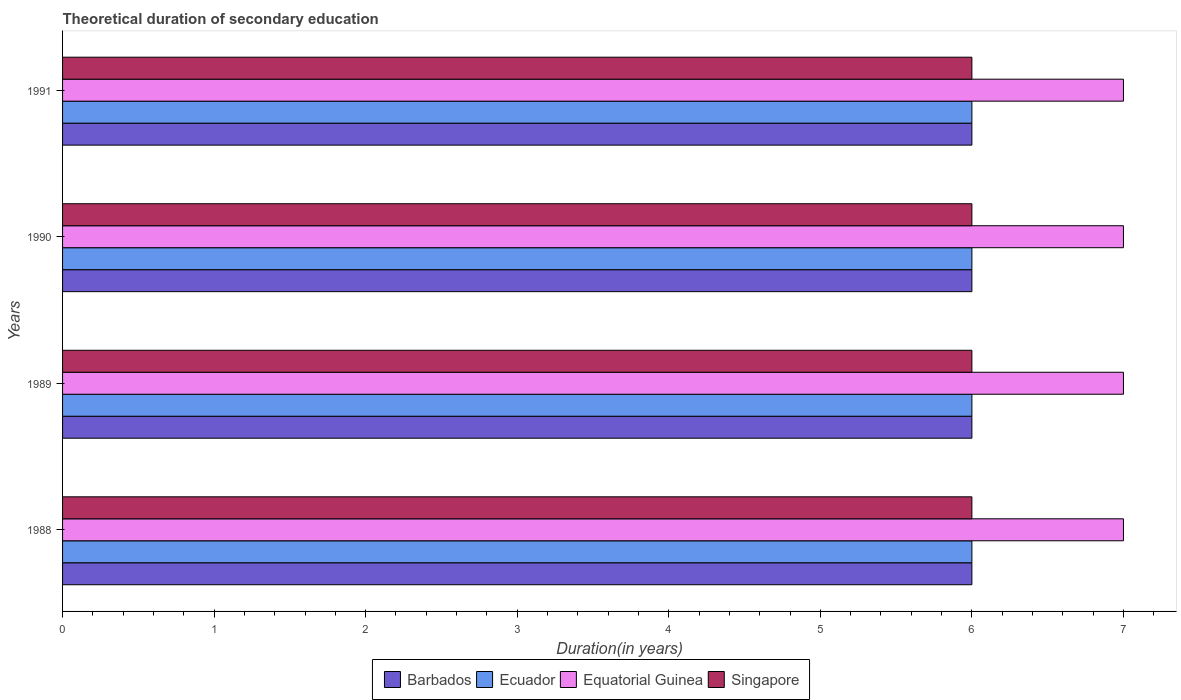How many different coloured bars are there?
Provide a succinct answer. 4. How many groups of bars are there?
Provide a short and direct response. 4. Are the number of bars per tick equal to the number of legend labels?
Provide a short and direct response. Yes. Are the number of bars on each tick of the Y-axis equal?
Your response must be concise. Yes. What is the total theoretical duration of secondary education in Equatorial Guinea in 1990?
Provide a short and direct response. 7. Across all years, what is the maximum total theoretical duration of secondary education in Ecuador?
Provide a short and direct response. 6. Across all years, what is the minimum total theoretical duration of secondary education in Equatorial Guinea?
Give a very brief answer. 7. What is the total total theoretical duration of secondary education in Barbados in the graph?
Keep it short and to the point. 24. What is the difference between the total theoretical duration of secondary education in Equatorial Guinea in 1989 and that in 1990?
Offer a terse response. 0. What is the difference between the total theoretical duration of secondary education in Singapore in 1990 and the total theoretical duration of secondary education in Equatorial Guinea in 1991?
Your answer should be compact. -1. In how many years, is the total theoretical duration of secondary education in Ecuador greater than 6 years?
Offer a very short reply. 0. What is the ratio of the total theoretical duration of secondary education in Singapore in 1989 to that in 1990?
Make the answer very short. 1. What is the difference between the highest and the second highest total theoretical duration of secondary education in Singapore?
Provide a succinct answer. 0. In how many years, is the total theoretical duration of secondary education in Ecuador greater than the average total theoretical duration of secondary education in Ecuador taken over all years?
Make the answer very short. 0. Is it the case that in every year, the sum of the total theoretical duration of secondary education in Barbados and total theoretical duration of secondary education in Ecuador is greater than the sum of total theoretical duration of secondary education in Singapore and total theoretical duration of secondary education in Equatorial Guinea?
Your answer should be very brief. No. What does the 2nd bar from the top in 1990 represents?
Keep it short and to the point. Equatorial Guinea. What does the 2nd bar from the bottom in 1988 represents?
Your response must be concise. Ecuador. Is it the case that in every year, the sum of the total theoretical duration of secondary education in Barbados and total theoretical duration of secondary education in Singapore is greater than the total theoretical duration of secondary education in Ecuador?
Make the answer very short. Yes. Are all the bars in the graph horizontal?
Provide a succinct answer. Yes. How many years are there in the graph?
Your answer should be very brief. 4. Are the values on the major ticks of X-axis written in scientific E-notation?
Make the answer very short. No. Where does the legend appear in the graph?
Your response must be concise. Bottom center. How many legend labels are there?
Keep it short and to the point. 4. What is the title of the graph?
Make the answer very short. Theoretical duration of secondary education. What is the label or title of the X-axis?
Your answer should be compact. Duration(in years). What is the label or title of the Y-axis?
Ensure brevity in your answer.  Years. What is the Duration(in years) of Ecuador in 1988?
Offer a very short reply. 6. What is the Duration(in years) of Equatorial Guinea in 1988?
Provide a short and direct response. 7. What is the Duration(in years) in Barbados in 1989?
Keep it short and to the point. 6. What is the Duration(in years) of Ecuador in 1989?
Keep it short and to the point. 6. What is the Duration(in years) in Equatorial Guinea in 1989?
Your answer should be compact. 7. What is the Duration(in years) in Singapore in 1989?
Give a very brief answer. 6. What is the Duration(in years) of Barbados in 1990?
Your answer should be very brief. 6. What is the Duration(in years) in Barbados in 1991?
Your answer should be very brief. 6. Across all years, what is the maximum Duration(in years) of Barbados?
Offer a very short reply. 6. Across all years, what is the maximum Duration(in years) of Ecuador?
Make the answer very short. 6. Across all years, what is the maximum Duration(in years) in Equatorial Guinea?
Offer a very short reply. 7. Across all years, what is the minimum Duration(in years) of Barbados?
Your response must be concise. 6. What is the total Duration(in years) of Barbados in the graph?
Provide a short and direct response. 24. What is the total Duration(in years) in Equatorial Guinea in the graph?
Provide a succinct answer. 28. What is the difference between the Duration(in years) in Barbados in 1988 and that in 1989?
Offer a terse response. 0. What is the difference between the Duration(in years) of Ecuador in 1988 and that in 1989?
Your response must be concise. 0. What is the difference between the Duration(in years) of Singapore in 1988 and that in 1989?
Provide a short and direct response. 0. What is the difference between the Duration(in years) in Barbados in 1988 and that in 1990?
Keep it short and to the point. 0. What is the difference between the Duration(in years) in Ecuador in 1988 and that in 1990?
Give a very brief answer. 0. What is the difference between the Duration(in years) of Equatorial Guinea in 1988 and that in 1990?
Your response must be concise. 0. What is the difference between the Duration(in years) of Singapore in 1988 and that in 1990?
Give a very brief answer. 0. What is the difference between the Duration(in years) in Ecuador in 1988 and that in 1991?
Offer a terse response. 0. What is the difference between the Duration(in years) in Equatorial Guinea in 1988 and that in 1991?
Ensure brevity in your answer.  0. What is the difference between the Duration(in years) of Singapore in 1988 and that in 1991?
Offer a very short reply. 0. What is the difference between the Duration(in years) of Ecuador in 1989 and that in 1990?
Provide a succinct answer. 0. What is the difference between the Duration(in years) in Singapore in 1989 and that in 1990?
Offer a terse response. 0. What is the difference between the Duration(in years) of Equatorial Guinea in 1990 and that in 1991?
Your answer should be compact. 0. What is the difference between the Duration(in years) of Singapore in 1990 and that in 1991?
Your response must be concise. 0. What is the difference between the Duration(in years) of Equatorial Guinea in 1988 and the Duration(in years) of Singapore in 1989?
Provide a succinct answer. 1. What is the difference between the Duration(in years) in Barbados in 1988 and the Duration(in years) in Ecuador in 1990?
Provide a succinct answer. 0. What is the difference between the Duration(in years) of Barbados in 1988 and the Duration(in years) of Equatorial Guinea in 1990?
Ensure brevity in your answer.  -1. What is the difference between the Duration(in years) in Ecuador in 1988 and the Duration(in years) in Singapore in 1990?
Make the answer very short. 0. What is the difference between the Duration(in years) in Barbados in 1988 and the Duration(in years) in Ecuador in 1991?
Offer a very short reply. 0. What is the difference between the Duration(in years) of Barbados in 1988 and the Duration(in years) of Equatorial Guinea in 1991?
Keep it short and to the point. -1. What is the difference between the Duration(in years) of Ecuador in 1988 and the Duration(in years) of Equatorial Guinea in 1991?
Keep it short and to the point. -1. What is the difference between the Duration(in years) in Ecuador in 1988 and the Duration(in years) in Singapore in 1991?
Offer a terse response. 0. What is the difference between the Duration(in years) of Equatorial Guinea in 1988 and the Duration(in years) of Singapore in 1991?
Ensure brevity in your answer.  1. What is the difference between the Duration(in years) of Barbados in 1989 and the Duration(in years) of Ecuador in 1990?
Keep it short and to the point. 0. What is the difference between the Duration(in years) in Ecuador in 1989 and the Duration(in years) in Equatorial Guinea in 1990?
Ensure brevity in your answer.  -1. What is the difference between the Duration(in years) in Barbados in 1989 and the Duration(in years) in Equatorial Guinea in 1991?
Offer a very short reply. -1. What is the difference between the Duration(in years) of Equatorial Guinea in 1989 and the Duration(in years) of Singapore in 1991?
Your response must be concise. 1. What is the difference between the Duration(in years) of Equatorial Guinea in 1990 and the Duration(in years) of Singapore in 1991?
Your answer should be very brief. 1. What is the average Duration(in years) of Barbados per year?
Your answer should be very brief. 6. In the year 1988, what is the difference between the Duration(in years) of Barbados and Duration(in years) of Equatorial Guinea?
Provide a succinct answer. -1. In the year 1988, what is the difference between the Duration(in years) of Barbados and Duration(in years) of Singapore?
Keep it short and to the point. 0. In the year 1988, what is the difference between the Duration(in years) in Ecuador and Duration(in years) in Equatorial Guinea?
Make the answer very short. -1. In the year 1989, what is the difference between the Duration(in years) of Barbados and Duration(in years) of Ecuador?
Your answer should be very brief. 0. In the year 1990, what is the difference between the Duration(in years) in Barbados and Duration(in years) in Equatorial Guinea?
Provide a succinct answer. -1. In the year 1990, what is the difference between the Duration(in years) of Barbados and Duration(in years) of Singapore?
Keep it short and to the point. 0. In the year 1990, what is the difference between the Duration(in years) of Equatorial Guinea and Duration(in years) of Singapore?
Give a very brief answer. 1. In the year 1991, what is the difference between the Duration(in years) of Barbados and Duration(in years) of Ecuador?
Your response must be concise. 0. In the year 1991, what is the difference between the Duration(in years) of Barbados and Duration(in years) of Equatorial Guinea?
Provide a succinct answer. -1. In the year 1991, what is the difference between the Duration(in years) in Ecuador and Duration(in years) in Equatorial Guinea?
Offer a very short reply. -1. What is the ratio of the Duration(in years) of Ecuador in 1988 to that in 1989?
Offer a very short reply. 1. What is the ratio of the Duration(in years) of Singapore in 1988 to that in 1989?
Provide a succinct answer. 1. What is the ratio of the Duration(in years) in Equatorial Guinea in 1988 to that in 1991?
Your answer should be very brief. 1. What is the ratio of the Duration(in years) of Barbados in 1989 to that in 1990?
Make the answer very short. 1. What is the ratio of the Duration(in years) in Equatorial Guinea in 1989 to that in 1990?
Ensure brevity in your answer.  1. What is the ratio of the Duration(in years) in Barbados in 1989 to that in 1991?
Ensure brevity in your answer.  1. What is the ratio of the Duration(in years) in Barbados in 1990 to that in 1991?
Make the answer very short. 1. What is the ratio of the Duration(in years) in Equatorial Guinea in 1990 to that in 1991?
Give a very brief answer. 1. What is the ratio of the Duration(in years) in Singapore in 1990 to that in 1991?
Make the answer very short. 1. What is the difference between the highest and the second highest Duration(in years) of Barbados?
Provide a succinct answer. 0. What is the difference between the highest and the second highest Duration(in years) of Equatorial Guinea?
Your response must be concise. 0. What is the difference between the highest and the second highest Duration(in years) of Singapore?
Offer a very short reply. 0. What is the difference between the highest and the lowest Duration(in years) in Barbados?
Make the answer very short. 0. What is the difference between the highest and the lowest Duration(in years) of Equatorial Guinea?
Offer a terse response. 0. 